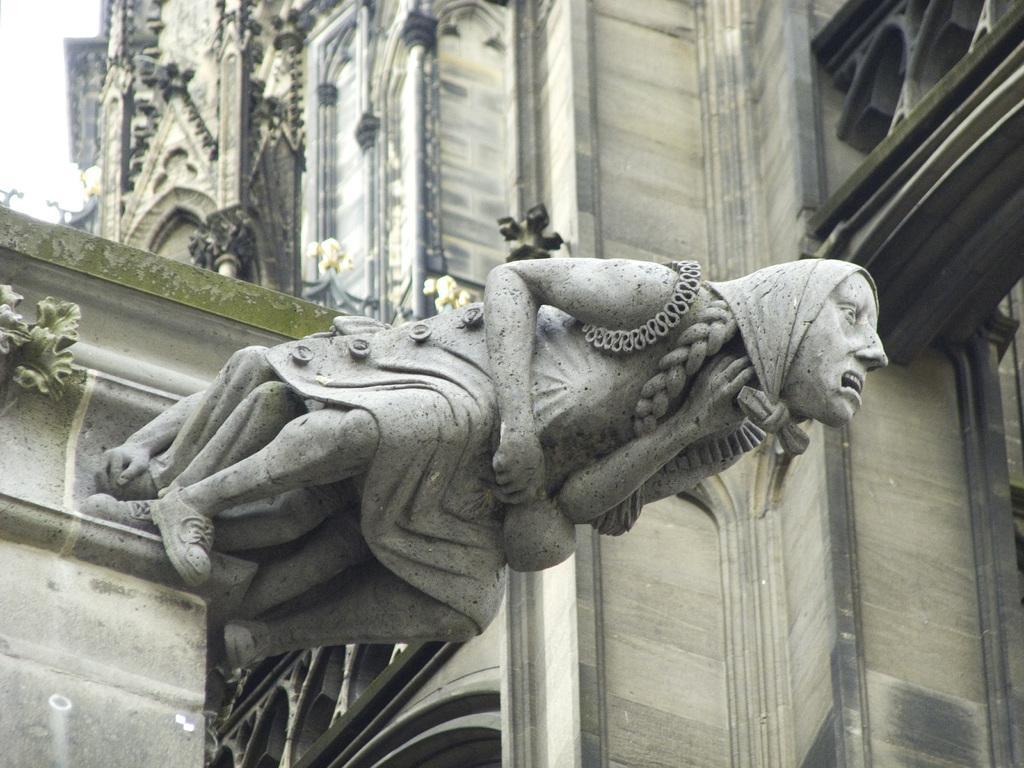How would you summarize this image in a sentence or two? In this image in the middle, there is an architecture. In the background there is a building, steeple and sky. 